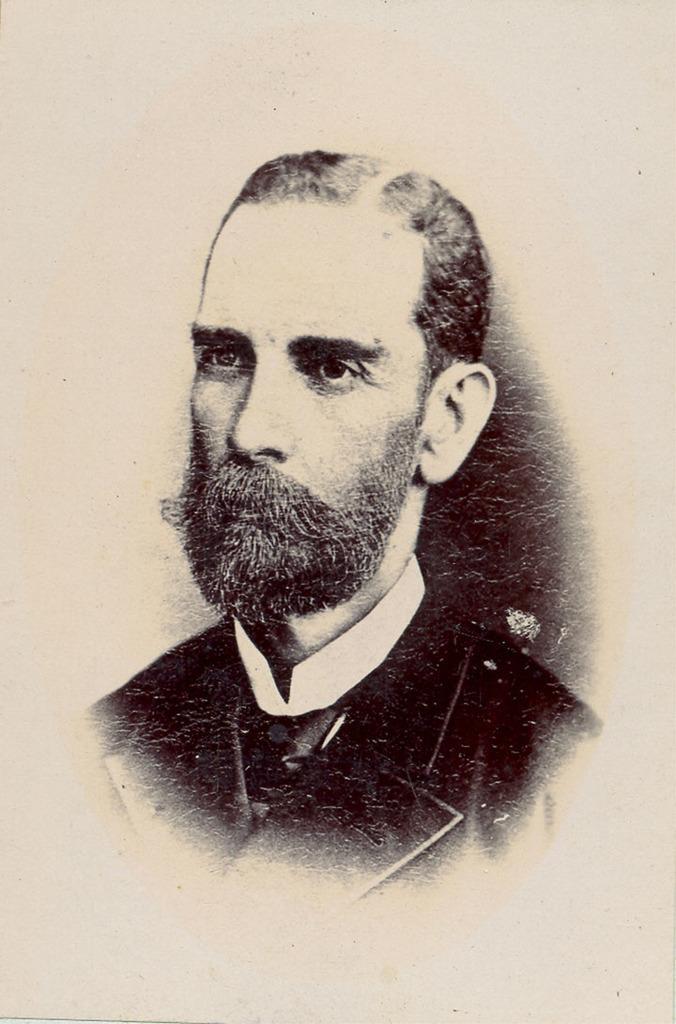How would you summarize this image in a sentence or two? In this image there is a picture of a person. 